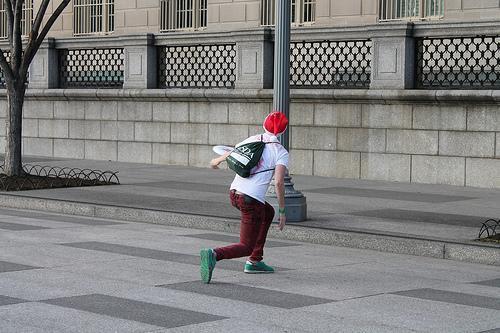How many santa hats are worn?
Give a very brief answer. 1. 